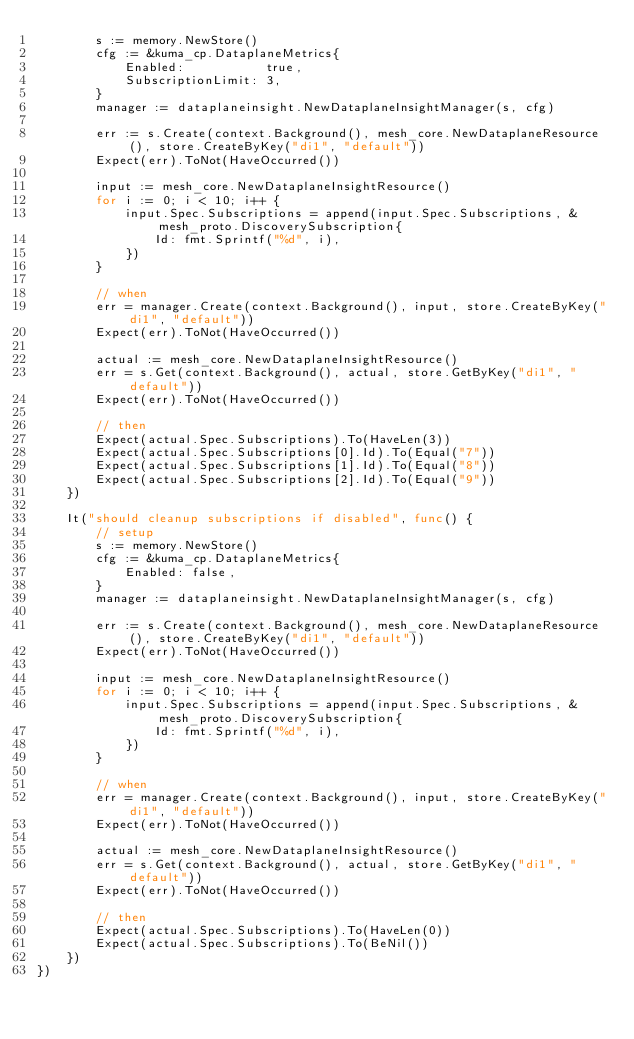Convert code to text. <code><loc_0><loc_0><loc_500><loc_500><_Go_>		s := memory.NewStore()
		cfg := &kuma_cp.DataplaneMetrics{
			Enabled:           true,
			SubscriptionLimit: 3,
		}
		manager := dataplaneinsight.NewDataplaneInsightManager(s, cfg)

		err := s.Create(context.Background(), mesh_core.NewDataplaneResource(), store.CreateByKey("di1", "default"))
		Expect(err).ToNot(HaveOccurred())

		input := mesh_core.NewDataplaneInsightResource()
		for i := 0; i < 10; i++ {
			input.Spec.Subscriptions = append(input.Spec.Subscriptions, &mesh_proto.DiscoverySubscription{
				Id: fmt.Sprintf("%d", i),
			})
		}

		// when
		err = manager.Create(context.Background(), input, store.CreateByKey("di1", "default"))
		Expect(err).ToNot(HaveOccurred())

		actual := mesh_core.NewDataplaneInsightResource()
		err = s.Get(context.Background(), actual, store.GetByKey("di1", "default"))
		Expect(err).ToNot(HaveOccurred())

		// then
		Expect(actual.Spec.Subscriptions).To(HaveLen(3))
		Expect(actual.Spec.Subscriptions[0].Id).To(Equal("7"))
		Expect(actual.Spec.Subscriptions[1].Id).To(Equal("8"))
		Expect(actual.Spec.Subscriptions[2].Id).To(Equal("9"))
	})

	It("should cleanup subscriptions if disabled", func() {
		// setup
		s := memory.NewStore()
		cfg := &kuma_cp.DataplaneMetrics{
			Enabled: false,
		}
		manager := dataplaneinsight.NewDataplaneInsightManager(s, cfg)

		err := s.Create(context.Background(), mesh_core.NewDataplaneResource(), store.CreateByKey("di1", "default"))
		Expect(err).ToNot(HaveOccurred())

		input := mesh_core.NewDataplaneInsightResource()
		for i := 0; i < 10; i++ {
			input.Spec.Subscriptions = append(input.Spec.Subscriptions, &mesh_proto.DiscoverySubscription{
				Id: fmt.Sprintf("%d", i),
			})
		}

		// when
		err = manager.Create(context.Background(), input, store.CreateByKey("di1", "default"))
		Expect(err).ToNot(HaveOccurred())

		actual := mesh_core.NewDataplaneInsightResource()
		err = s.Get(context.Background(), actual, store.GetByKey("di1", "default"))
		Expect(err).ToNot(HaveOccurred())

		// then
		Expect(actual.Spec.Subscriptions).To(HaveLen(0))
		Expect(actual.Spec.Subscriptions).To(BeNil())
	})
})
</code> 